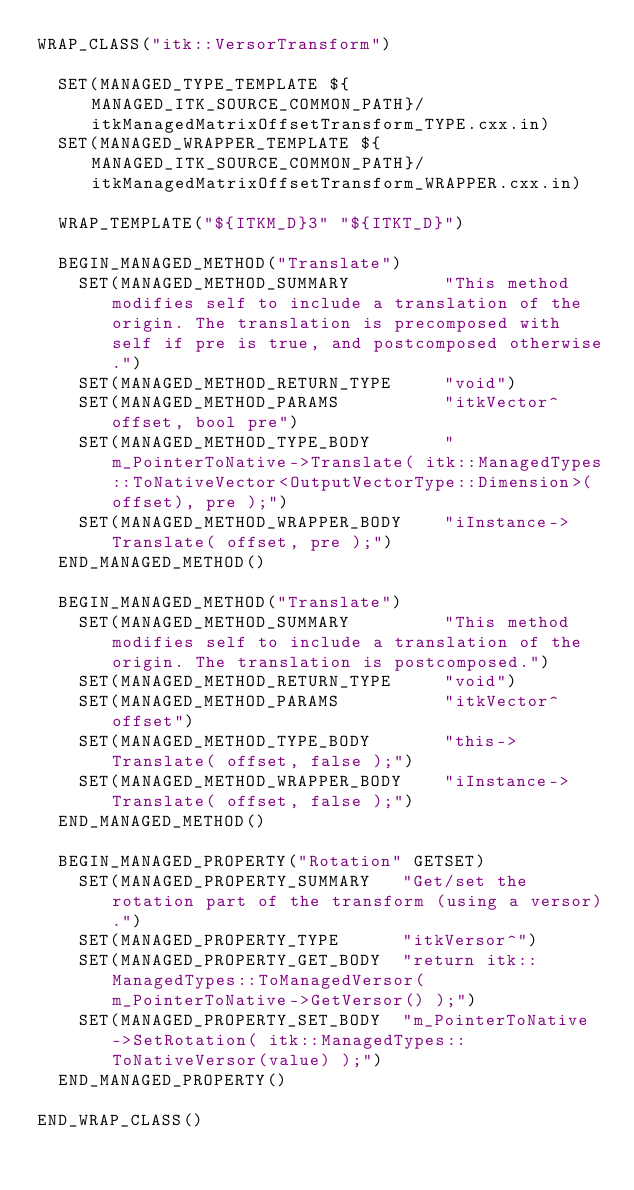<code> <loc_0><loc_0><loc_500><loc_500><_CMake_>WRAP_CLASS("itk::VersorTransform")

  SET(MANAGED_TYPE_TEMPLATE ${MANAGED_ITK_SOURCE_COMMON_PATH}/itkManagedMatrixOffsetTransform_TYPE.cxx.in)
  SET(MANAGED_WRAPPER_TEMPLATE ${MANAGED_ITK_SOURCE_COMMON_PATH}/itkManagedMatrixOffsetTransform_WRAPPER.cxx.in)

  WRAP_TEMPLATE("${ITKM_D}3" "${ITKT_D}")

  BEGIN_MANAGED_METHOD("Translate")
    SET(MANAGED_METHOD_SUMMARY         "This method modifies self to include a translation of the origin. The translation is precomposed with self if pre is true, and postcomposed otherwise.")
    SET(MANAGED_METHOD_RETURN_TYPE     "void")
    SET(MANAGED_METHOD_PARAMS          "itkVector^ offset, bool pre")
    SET(MANAGED_METHOD_TYPE_BODY       "m_PointerToNative->Translate( itk::ManagedTypes::ToNativeVector<OutputVectorType::Dimension>(offset), pre );")
    SET(MANAGED_METHOD_WRAPPER_BODY    "iInstance->Translate( offset, pre );")
  END_MANAGED_METHOD()
  
  BEGIN_MANAGED_METHOD("Translate")
    SET(MANAGED_METHOD_SUMMARY         "This method modifies self to include a translation of the origin. The translation is postcomposed.")
    SET(MANAGED_METHOD_RETURN_TYPE     "void")
    SET(MANAGED_METHOD_PARAMS          "itkVector^ offset")
    SET(MANAGED_METHOD_TYPE_BODY       "this->Translate( offset, false );")
    SET(MANAGED_METHOD_WRAPPER_BODY    "iInstance->Translate( offset, false );")
  END_MANAGED_METHOD()

  BEGIN_MANAGED_PROPERTY("Rotation" GETSET)
    SET(MANAGED_PROPERTY_SUMMARY   "Get/set the rotation part of the transform (using a versor).")
    SET(MANAGED_PROPERTY_TYPE      "itkVersor^")
    SET(MANAGED_PROPERTY_GET_BODY  "return itk::ManagedTypes::ToManagedVersor( m_PointerToNative->GetVersor() );")
    SET(MANAGED_PROPERTY_SET_BODY  "m_PointerToNative->SetRotation( itk::ManagedTypes::ToNativeVersor(value) );")
  END_MANAGED_PROPERTY()

END_WRAP_CLASS()
</code> 